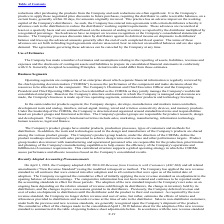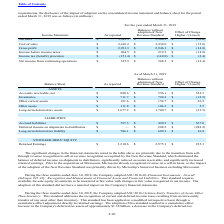According to Microchip Technology's financial document, What was the reported net sales? According to the financial document, 5,349.5 (in millions). The relevant text states: "Net sales $ 5,349.5 $ 5,380.1 $ (30.6)..." Also, What was the change in cost of sales due to the standard? According to the financial document, (15.8) (in millions). The relevant text states: "Cost of sales $ 2,418.2 $ 2,434.0 $ (15.8)..." Also, What was the Balances without adoption of New Revenue Standard for gross profit? According to the financial document, 2,946.1 (in millions). The relevant text states: "Gross profit $ 2,931.3 $ 2,946.1 $ (14.8)..." Also, can you calculate: What was the difference in amount as reported between net sales and cost of sales? Based on the calculation: 5,349.5-2,418.2, the result is 2931.3 (in millions). This is based on the information: "Cost of sales $ 2,418.2 $ 2,434.0 $ (15.8) Net sales $ 5,349.5 $ 5,380.1 $ (30.6)..." The key data points involved are: 2,418.2, 5,349.5. Also, can you calculate: What was the difference between Net income from continuing operations and Income before income taxes? Based on the calculation: 355.9-204.5, the result is 151.4 (in millions). This is based on the information: "Income before income taxes $ 204.5 $ 219.3 $ (14.8) Net income from continuing operations $ 355.9 $ 368.3 $ (12.4)..." The key data points involved are: 204.5, 355.9. Additionally, Which reported amounts exceeded $3,000 million? According to the financial document, Net sales. The relevant text states: "doption of the new standard impacts the Company's net sales on an ongoing basis depending on the relative amount of revenue sold through its distributors, the..." 